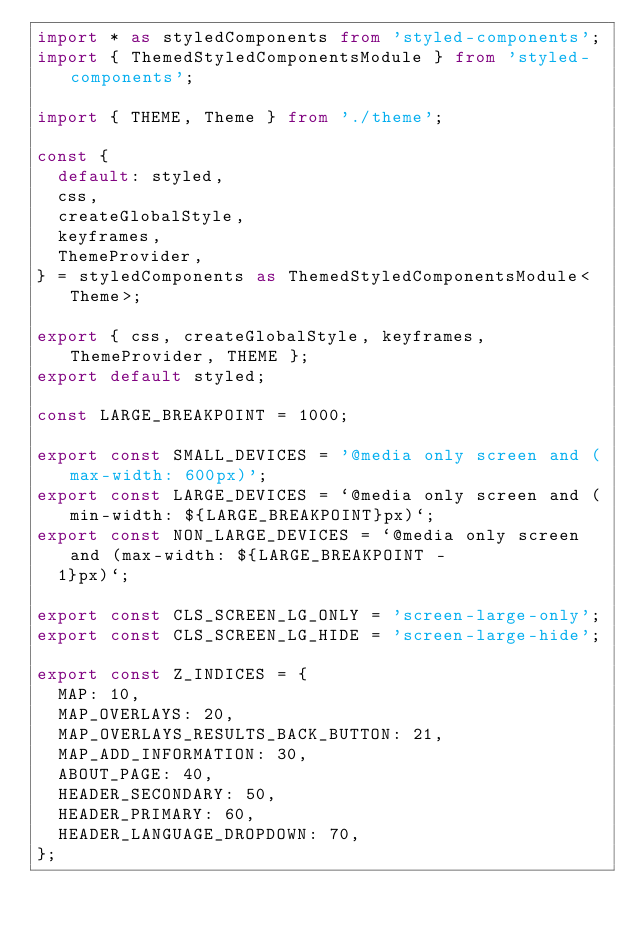<code> <loc_0><loc_0><loc_500><loc_500><_TypeScript_>import * as styledComponents from 'styled-components';
import { ThemedStyledComponentsModule } from 'styled-components';

import { THEME, Theme } from './theme';

const {
  default: styled,
  css,
  createGlobalStyle,
  keyframes,
  ThemeProvider,
} = styledComponents as ThemedStyledComponentsModule<Theme>;

export { css, createGlobalStyle, keyframes, ThemeProvider, THEME };
export default styled;

const LARGE_BREAKPOINT = 1000;

export const SMALL_DEVICES = '@media only screen and (max-width: 600px)';
export const LARGE_DEVICES = `@media only screen and (min-width: ${LARGE_BREAKPOINT}px)`;
export const NON_LARGE_DEVICES = `@media only screen and (max-width: ${LARGE_BREAKPOINT -
  1}px)`;

export const CLS_SCREEN_LG_ONLY = 'screen-large-only';
export const CLS_SCREEN_LG_HIDE = 'screen-large-hide';

export const Z_INDICES = {
  MAP: 10,
  MAP_OVERLAYS: 20,
  MAP_OVERLAYS_RESULTS_BACK_BUTTON: 21,
  MAP_ADD_INFORMATION: 30,
  ABOUT_PAGE: 40,
  HEADER_SECONDARY: 50,
  HEADER_PRIMARY: 60,
  HEADER_LANGUAGE_DROPDOWN: 70,
};
</code> 